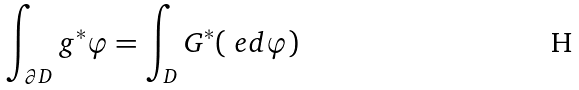Convert formula to latex. <formula><loc_0><loc_0><loc_500><loc_500>\int _ { \partial D } g ^ { * } \varphi = \int _ { D } G ^ { * } ( \ e d \varphi )</formula> 